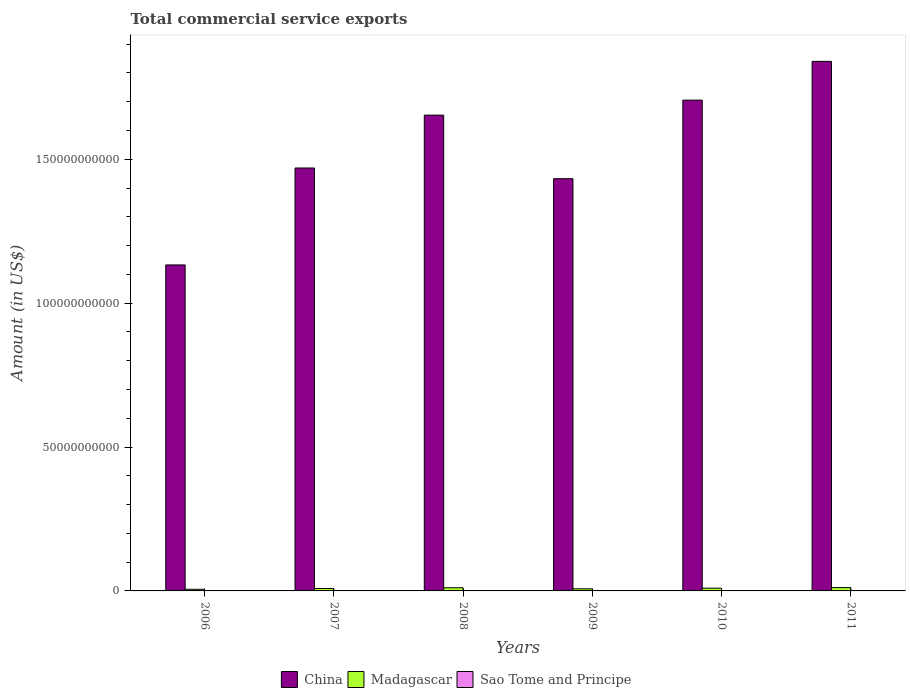Are the number of bars per tick equal to the number of legend labels?
Give a very brief answer. Yes. Are the number of bars on each tick of the X-axis equal?
Ensure brevity in your answer.  Yes. What is the label of the 3rd group of bars from the left?
Ensure brevity in your answer.  2008. What is the total commercial service exports in Sao Tome and Principe in 2009?
Provide a short and direct response. 1.01e+07. Across all years, what is the maximum total commercial service exports in China?
Offer a very short reply. 1.84e+11. Across all years, what is the minimum total commercial service exports in Sao Tome and Principe?
Give a very brief answer. 6.43e+06. In which year was the total commercial service exports in Sao Tome and Principe maximum?
Provide a short and direct response. 2011. What is the total total commercial service exports in China in the graph?
Provide a short and direct response. 9.23e+11. What is the difference between the total commercial service exports in Madagascar in 2009 and that in 2010?
Give a very brief answer. -2.25e+08. What is the difference between the total commercial service exports in China in 2009 and the total commercial service exports in Madagascar in 2006?
Offer a terse response. 1.43e+11. What is the average total commercial service exports in China per year?
Provide a short and direct response. 1.54e+11. In the year 2006, what is the difference between the total commercial service exports in Madagascar and total commercial service exports in Sao Tome and Principe?
Give a very brief answer. 5.56e+08. In how many years, is the total commercial service exports in China greater than 60000000000 US$?
Provide a short and direct response. 6. What is the ratio of the total commercial service exports in Madagascar in 2010 to that in 2011?
Your answer should be compact. 0.83. What is the difference between the highest and the second highest total commercial service exports in Sao Tome and Principe?
Your answer should be compact. 4.98e+06. What is the difference between the highest and the lowest total commercial service exports in China?
Provide a short and direct response. 7.07e+1. What does the 2nd bar from the left in 2009 represents?
Offer a very short reply. Madagascar. What does the 1st bar from the right in 2009 represents?
Give a very brief answer. Sao Tome and Principe. Is it the case that in every year, the sum of the total commercial service exports in Sao Tome and Principe and total commercial service exports in China is greater than the total commercial service exports in Madagascar?
Your answer should be very brief. Yes. How many bars are there?
Offer a very short reply. 18. How many years are there in the graph?
Ensure brevity in your answer.  6. What is the difference between two consecutive major ticks on the Y-axis?
Provide a short and direct response. 5.00e+1. Are the values on the major ticks of Y-axis written in scientific E-notation?
Keep it short and to the point. No. Does the graph contain any zero values?
Your response must be concise. No. How many legend labels are there?
Provide a short and direct response. 3. What is the title of the graph?
Your answer should be very brief. Total commercial service exports. Does "High income" appear as one of the legend labels in the graph?
Make the answer very short. No. What is the Amount (in US$) in China in 2006?
Give a very brief answer. 1.13e+11. What is the Amount (in US$) in Madagascar in 2006?
Ensure brevity in your answer.  5.65e+08. What is the Amount (in US$) in Sao Tome and Principe in 2006?
Your response must be concise. 8.14e+06. What is the Amount (in US$) of China in 2007?
Your response must be concise. 1.47e+11. What is the Amount (in US$) of Madagascar in 2007?
Provide a short and direct response. 8.46e+08. What is the Amount (in US$) in Sao Tome and Principe in 2007?
Give a very brief answer. 6.43e+06. What is the Amount (in US$) of China in 2008?
Make the answer very short. 1.65e+11. What is the Amount (in US$) in Madagascar in 2008?
Provide a short and direct response. 1.10e+09. What is the Amount (in US$) in Sao Tome and Principe in 2008?
Ensure brevity in your answer.  9.37e+06. What is the Amount (in US$) in China in 2009?
Offer a terse response. 1.43e+11. What is the Amount (in US$) of Madagascar in 2009?
Your response must be concise. 7.36e+08. What is the Amount (in US$) of Sao Tome and Principe in 2009?
Your answer should be compact. 1.01e+07. What is the Amount (in US$) in China in 2010?
Provide a succinct answer. 1.71e+11. What is the Amount (in US$) in Madagascar in 2010?
Provide a succinct answer. 9.61e+08. What is the Amount (in US$) in Sao Tome and Principe in 2010?
Provide a succinct answer. 1.30e+07. What is the Amount (in US$) in China in 2011?
Keep it short and to the point. 1.84e+11. What is the Amount (in US$) of Madagascar in 2011?
Your response must be concise. 1.16e+09. What is the Amount (in US$) in Sao Tome and Principe in 2011?
Keep it short and to the point. 1.80e+07. Across all years, what is the maximum Amount (in US$) in China?
Provide a succinct answer. 1.84e+11. Across all years, what is the maximum Amount (in US$) in Madagascar?
Your answer should be compact. 1.16e+09. Across all years, what is the maximum Amount (in US$) in Sao Tome and Principe?
Provide a succinct answer. 1.80e+07. Across all years, what is the minimum Amount (in US$) in China?
Your answer should be compact. 1.13e+11. Across all years, what is the minimum Amount (in US$) in Madagascar?
Offer a very short reply. 5.65e+08. Across all years, what is the minimum Amount (in US$) of Sao Tome and Principe?
Provide a short and direct response. 6.43e+06. What is the total Amount (in US$) in China in the graph?
Give a very brief answer. 9.23e+11. What is the total Amount (in US$) in Madagascar in the graph?
Give a very brief answer. 5.37e+09. What is the total Amount (in US$) of Sao Tome and Principe in the graph?
Your answer should be compact. 6.50e+07. What is the difference between the Amount (in US$) in China in 2006 and that in 2007?
Give a very brief answer. -3.37e+1. What is the difference between the Amount (in US$) in Madagascar in 2006 and that in 2007?
Offer a terse response. -2.82e+08. What is the difference between the Amount (in US$) of Sao Tome and Principe in 2006 and that in 2007?
Give a very brief answer. 1.71e+06. What is the difference between the Amount (in US$) in China in 2006 and that in 2008?
Your answer should be very brief. -5.21e+1. What is the difference between the Amount (in US$) of Madagascar in 2006 and that in 2008?
Make the answer very short. -5.37e+08. What is the difference between the Amount (in US$) of Sao Tome and Principe in 2006 and that in 2008?
Your answer should be very brief. -1.23e+06. What is the difference between the Amount (in US$) in China in 2006 and that in 2009?
Offer a terse response. -3.00e+1. What is the difference between the Amount (in US$) of Madagascar in 2006 and that in 2009?
Give a very brief answer. -1.71e+08. What is the difference between the Amount (in US$) in Sao Tome and Principe in 2006 and that in 2009?
Your answer should be compact. -1.94e+06. What is the difference between the Amount (in US$) of China in 2006 and that in 2010?
Make the answer very short. -5.73e+1. What is the difference between the Amount (in US$) of Madagascar in 2006 and that in 2010?
Your answer should be very brief. -3.97e+08. What is the difference between the Amount (in US$) of Sao Tome and Principe in 2006 and that in 2010?
Your answer should be compact. -4.89e+06. What is the difference between the Amount (in US$) of China in 2006 and that in 2011?
Your response must be concise. -7.07e+1. What is the difference between the Amount (in US$) of Madagascar in 2006 and that in 2011?
Provide a short and direct response. -5.96e+08. What is the difference between the Amount (in US$) of Sao Tome and Principe in 2006 and that in 2011?
Offer a terse response. -9.87e+06. What is the difference between the Amount (in US$) in China in 2007 and that in 2008?
Your response must be concise. -1.84e+1. What is the difference between the Amount (in US$) of Madagascar in 2007 and that in 2008?
Make the answer very short. -2.55e+08. What is the difference between the Amount (in US$) in Sao Tome and Principe in 2007 and that in 2008?
Your response must be concise. -2.94e+06. What is the difference between the Amount (in US$) of China in 2007 and that in 2009?
Offer a terse response. 3.72e+09. What is the difference between the Amount (in US$) in Madagascar in 2007 and that in 2009?
Give a very brief answer. 1.10e+08. What is the difference between the Amount (in US$) of Sao Tome and Principe in 2007 and that in 2009?
Your answer should be compact. -3.64e+06. What is the difference between the Amount (in US$) in China in 2007 and that in 2010?
Provide a succinct answer. -2.36e+1. What is the difference between the Amount (in US$) in Madagascar in 2007 and that in 2010?
Ensure brevity in your answer.  -1.15e+08. What is the difference between the Amount (in US$) of Sao Tome and Principe in 2007 and that in 2010?
Provide a short and direct response. -6.59e+06. What is the difference between the Amount (in US$) in China in 2007 and that in 2011?
Your response must be concise. -3.71e+1. What is the difference between the Amount (in US$) in Madagascar in 2007 and that in 2011?
Your response must be concise. -3.14e+08. What is the difference between the Amount (in US$) in Sao Tome and Principe in 2007 and that in 2011?
Give a very brief answer. -1.16e+07. What is the difference between the Amount (in US$) in China in 2008 and that in 2009?
Offer a very short reply. 2.21e+1. What is the difference between the Amount (in US$) in Madagascar in 2008 and that in 2009?
Your answer should be compact. 3.65e+08. What is the difference between the Amount (in US$) of Sao Tome and Principe in 2008 and that in 2009?
Give a very brief answer. -7.04e+05. What is the difference between the Amount (in US$) of China in 2008 and that in 2010?
Your answer should be very brief. -5.21e+09. What is the difference between the Amount (in US$) in Madagascar in 2008 and that in 2010?
Your answer should be very brief. 1.40e+08. What is the difference between the Amount (in US$) of Sao Tome and Principe in 2008 and that in 2010?
Provide a succinct answer. -3.65e+06. What is the difference between the Amount (in US$) of China in 2008 and that in 2011?
Your answer should be compact. -1.87e+1. What is the difference between the Amount (in US$) in Madagascar in 2008 and that in 2011?
Ensure brevity in your answer.  -5.88e+07. What is the difference between the Amount (in US$) in Sao Tome and Principe in 2008 and that in 2011?
Provide a short and direct response. -8.64e+06. What is the difference between the Amount (in US$) in China in 2009 and that in 2010?
Offer a terse response. -2.73e+1. What is the difference between the Amount (in US$) of Madagascar in 2009 and that in 2010?
Your response must be concise. -2.25e+08. What is the difference between the Amount (in US$) in Sao Tome and Principe in 2009 and that in 2010?
Offer a terse response. -2.95e+06. What is the difference between the Amount (in US$) of China in 2009 and that in 2011?
Keep it short and to the point. -4.08e+1. What is the difference between the Amount (in US$) of Madagascar in 2009 and that in 2011?
Offer a terse response. -4.24e+08. What is the difference between the Amount (in US$) of Sao Tome and Principe in 2009 and that in 2011?
Offer a terse response. -7.93e+06. What is the difference between the Amount (in US$) in China in 2010 and that in 2011?
Give a very brief answer. -1.35e+1. What is the difference between the Amount (in US$) in Madagascar in 2010 and that in 2011?
Your answer should be very brief. -1.99e+08. What is the difference between the Amount (in US$) in Sao Tome and Principe in 2010 and that in 2011?
Provide a succinct answer. -4.98e+06. What is the difference between the Amount (in US$) in China in 2006 and the Amount (in US$) in Madagascar in 2007?
Your response must be concise. 1.12e+11. What is the difference between the Amount (in US$) in China in 2006 and the Amount (in US$) in Sao Tome and Principe in 2007?
Keep it short and to the point. 1.13e+11. What is the difference between the Amount (in US$) of Madagascar in 2006 and the Amount (in US$) of Sao Tome and Principe in 2007?
Provide a short and direct response. 5.58e+08. What is the difference between the Amount (in US$) in China in 2006 and the Amount (in US$) in Madagascar in 2008?
Offer a very short reply. 1.12e+11. What is the difference between the Amount (in US$) in China in 2006 and the Amount (in US$) in Sao Tome and Principe in 2008?
Give a very brief answer. 1.13e+11. What is the difference between the Amount (in US$) of Madagascar in 2006 and the Amount (in US$) of Sao Tome and Principe in 2008?
Provide a succinct answer. 5.55e+08. What is the difference between the Amount (in US$) in China in 2006 and the Amount (in US$) in Madagascar in 2009?
Offer a very short reply. 1.13e+11. What is the difference between the Amount (in US$) of China in 2006 and the Amount (in US$) of Sao Tome and Principe in 2009?
Your answer should be very brief. 1.13e+11. What is the difference between the Amount (in US$) in Madagascar in 2006 and the Amount (in US$) in Sao Tome and Principe in 2009?
Ensure brevity in your answer.  5.55e+08. What is the difference between the Amount (in US$) in China in 2006 and the Amount (in US$) in Madagascar in 2010?
Provide a succinct answer. 1.12e+11. What is the difference between the Amount (in US$) in China in 2006 and the Amount (in US$) in Sao Tome and Principe in 2010?
Offer a terse response. 1.13e+11. What is the difference between the Amount (in US$) of Madagascar in 2006 and the Amount (in US$) of Sao Tome and Principe in 2010?
Offer a terse response. 5.52e+08. What is the difference between the Amount (in US$) in China in 2006 and the Amount (in US$) in Madagascar in 2011?
Your response must be concise. 1.12e+11. What is the difference between the Amount (in US$) of China in 2006 and the Amount (in US$) of Sao Tome and Principe in 2011?
Your answer should be compact. 1.13e+11. What is the difference between the Amount (in US$) of Madagascar in 2006 and the Amount (in US$) of Sao Tome and Principe in 2011?
Your answer should be compact. 5.47e+08. What is the difference between the Amount (in US$) in China in 2007 and the Amount (in US$) in Madagascar in 2008?
Ensure brevity in your answer.  1.46e+11. What is the difference between the Amount (in US$) in China in 2007 and the Amount (in US$) in Sao Tome and Principe in 2008?
Offer a very short reply. 1.47e+11. What is the difference between the Amount (in US$) of Madagascar in 2007 and the Amount (in US$) of Sao Tome and Principe in 2008?
Provide a succinct answer. 8.37e+08. What is the difference between the Amount (in US$) in China in 2007 and the Amount (in US$) in Madagascar in 2009?
Your response must be concise. 1.46e+11. What is the difference between the Amount (in US$) of China in 2007 and the Amount (in US$) of Sao Tome and Principe in 2009?
Ensure brevity in your answer.  1.47e+11. What is the difference between the Amount (in US$) in Madagascar in 2007 and the Amount (in US$) in Sao Tome and Principe in 2009?
Your answer should be very brief. 8.36e+08. What is the difference between the Amount (in US$) of China in 2007 and the Amount (in US$) of Madagascar in 2010?
Ensure brevity in your answer.  1.46e+11. What is the difference between the Amount (in US$) in China in 2007 and the Amount (in US$) in Sao Tome and Principe in 2010?
Your answer should be compact. 1.47e+11. What is the difference between the Amount (in US$) in Madagascar in 2007 and the Amount (in US$) in Sao Tome and Principe in 2010?
Your answer should be compact. 8.33e+08. What is the difference between the Amount (in US$) in China in 2007 and the Amount (in US$) in Madagascar in 2011?
Your answer should be very brief. 1.46e+11. What is the difference between the Amount (in US$) of China in 2007 and the Amount (in US$) of Sao Tome and Principe in 2011?
Keep it short and to the point. 1.47e+11. What is the difference between the Amount (in US$) in Madagascar in 2007 and the Amount (in US$) in Sao Tome and Principe in 2011?
Ensure brevity in your answer.  8.28e+08. What is the difference between the Amount (in US$) in China in 2008 and the Amount (in US$) in Madagascar in 2009?
Make the answer very short. 1.65e+11. What is the difference between the Amount (in US$) in China in 2008 and the Amount (in US$) in Sao Tome and Principe in 2009?
Your answer should be very brief. 1.65e+11. What is the difference between the Amount (in US$) of Madagascar in 2008 and the Amount (in US$) of Sao Tome and Principe in 2009?
Offer a very short reply. 1.09e+09. What is the difference between the Amount (in US$) of China in 2008 and the Amount (in US$) of Madagascar in 2010?
Your answer should be compact. 1.64e+11. What is the difference between the Amount (in US$) in China in 2008 and the Amount (in US$) in Sao Tome and Principe in 2010?
Keep it short and to the point. 1.65e+11. What is the difference between the Amount (in US$) of Madagascar in 2008 and the Amount (in US$) of Sao Tome and Principe in 2010?
Keep it short and to the point. 1.09e+09. What is the difference between the Amount (in US$) of China in 2008 and the Amount (in US$) of Madagascar in 2011?
Offer a terse response. 1.64e+11. What is the difference between the Amount (in US$) of China in 2008 and the Amount (in US$) of Sao Tome and Principe in 2011?
Offer a very short reply. 1.65e+11. What is the difference between the Amount (in US$) of Madagascar in 2008 and the Amount (in US$) of Sao Tome and Principe in 2011?
Your answer should be very brief. 1.08e+09. What is the difference between the Amount (in US$) in China in 2009 and the Amount (in US$) in Madagascar in 2010?
Your answer should be very brief. 1.42e+11. What is the difference between the Amount (in US$) in China in 2009 and the Amount (in US$) in Sao Tome and Principe in 2010?
Your response must be concise. 1.43e+11. What is the difference between the Amount (in US$) in Madagascar in 2009 and the Amount (in US$) in Sao Tome and Principe in 2010?
Provide a short and direct response. 7.23e+08. What is the difference between the Amount (in US$) in China in 2009 and the Amount (in US$) in Madagascar in 2011?
Keep it short and to the point. 1.42e+11. What is the difference between the Amount (in US$) of China in 2009 and the Amount (in US$) of Sao Tome and Principe in 2011?
Your answer should be very brief. 1.43e+11. What is the difference between the Amount (in US$) in Madagascar in 2009 and the Amount (in US$) in Sao Tome and Principe in 2011?
Your answer should be compact. 7.18e+08. What is the difference between the Amount (in US$) of China in 2010 and the Amount (in US$) of Madagascar in 2011?
Offer a very short reply. 1.69e+11. What is the difference between the Amount (in US$) of China in 2010 and the Amount (in US$) of Sao Tome and Principe in 2011?
Your response must be concise. 1.71e+11. What is the difference between the Amount (in US$) in Madagascar in 2010 and the Amount (in US$) in Sao Tome and Principe in 2011?
Provide a succinct answer. 9.43e+08. What is the average Amount (in US$) in China per year?
Your answer should be very brief. 1.54e+11. What is the average Amount (in US$) in Madagascar per year?
Ensure brevity in your answer.  8.95e+08. What is the average Amount (in US$) in Sao Tome and Principe per year?
Ensure brevity in your answer.  1.08e+07. In the year 2006, what is the difference between the Amount (in US$) in China and Amount (in US$) in Madagascar?
Offer a very short reply. 1.13e+11. In the year 2006, what is the difference between the Amount (in US$) of China and Amount (in US$) of Sao Tome and Principe?
Give a very brief answer. 1.13e+11. In the year 2006, what is the difference between the Amount (in US$) in Madagascar and Amount (in US$) in Sao Tome and Principe?
Give a very brief answer. 5.56e+08. In the year 2007, what is the difference between the Amount (in US$) in China and Amount (in US$) in Madagascar?
Your answer should be very brief. 1.46e+11. In the year 2007, what is the difference between the Amount (in US$) of China and Amount (in US$) of Sao Tome and Principe?
Make the answer very short. 1.47e+11. In the year 2007, what is the difference between the Amount (in US$) in Madagascar and Amount (in US$) in Sao Tome and Principe?
Your response must be concise. 8.40e+08. In the year 2008, what is the difference between the Amount (in US$) of China and Amount (in US$) of Madagascar?
Offer a very short reply. 1.64e+11. In the year 2008, what is the difference between the Amount (in US$) of China and Amount (in US$) of Sao Tome and Principe?
Your response must be concise. 1.65e+11. In the year 2008, what is the difference between the Amount (in US$) of Madagascar and Amount (in US$) of Sao Tome and Principe?
Offer a very short reply. 1.09e+09. In the year 2009, what is the difference between the Amount (in US$) of China and Amount (in US$) of Madagascar?
Make the answer very short. 1.42e+11. In the year 2009, what is the difference between the Amount (in US$) of China and Amount (in US$) of Sao Tome and Principe?
Offer a terse response. 1.43e+11. In the year 2009, what is the difference between the Amount (in US$) in Madagascar and Amount (in US$) in Sao Tome and Principe?
Your response must be concise. 7.26e+08. In the year 2010, what is the difference between the Amount (in US$) in China and Amount (in US$) in Madagascar?
Offer a very short reply. 1.70e+11. In the year 2010, what is the difference between the Amount (in US$) of China and Amount (in US$) of Sao Tome and Principe?
Provide a short and direct response. 1.71e+11. In the year 2010, what is the difference between the Amount (in US$) in Madagascar and Amount (in US$) in Sao Tome and Principe?
Make the answer very short. 9.48e+08. In the year 2011, what is the difference between the Amount (in US$) in China and Amount (in US$) in Madagascar?
Ensure brevity in your answer.  1.83e+11. In the year 2011, what is the difference between the Amount (in US$) of China and Amount (in US$) of Sao Tome and Principe?
Your answer should be compact. 1.84e+11. In the year 2011, what is the difference between the Amount (in US$) in Madagascar and Amount (in US$) in Sao Tome and Principe?
Your response must be concise. 1.14e+09. What is the ratio of the Amount (in US$) in China in 2006 to that in 2007?
Offer a very short reply. 0.77. What is the ratio of the Amount (in US$) of Madagascar in 2006 to that in 2007?
Your answer should be very brief. 0.67. What is the ratio of the Amount (in US$) of Sao Tome and Principe in 2006 to that in 2007?
Make the answer very short. 1.27. What is the ratio of the Amount (in US$) of China in 2006 to that in 2008?
Your answer should be very brief. 0.69. What is the ratio of the Amount (in US$) in Madagascar in 2006 to that in 2008?
Your answer should be compact. 0.51. What is the ratio of the Amount (in US$) in Sao Tome and Principe in 2006 to that in 2008?
Your response must be concise. 0.87. What is the ratio of the Amount (in US$) in China in 2006 to that in 2009?
Ensure brevity in your answer.  0.79. What is the ratio of the Amount (in US$) in Madagascar in 2006 to that in 2009?
Make the answer very short. 0.77. What is the ratio of the Amount (in US$) of Sao Tome and Principe in 2006 to that in 2009?
Provide a short and direct response. 0.81. What is the ratio of the Amount (in US$) in China in 2006 to that in 2010?
Keep it short and to the point. 0.66. What is the ratio of the Amount (in US$) of Madagascar in 2006 to that in 2010?
Keep it short and to the point. 0.59. What is the ratio of the Amount (in US$) in Sao Tome and Principe in 2006 to that in 2010?
Ensure brevity in your answer.  0.62. What is the ratio of the Amount (in US$) in China in 2006 to that in 2011?
Offer a terse response. 0.62. What is the ratio of the Amount (in US$) of Madagascar in 2006 to that in 2011?
Ensure brevity in your answer.  0.49. What is the ratio of the Amount (in US$) of Sao Tome and Principe in 2006 to that in 2011?
Make the answer very short. 0.45. What is the ratio of the Amount (in US$) of China in 2007 to that in 2008?
Ensure brevity in your answer.  0.89. What is the ratio of the Amount (in US$) of Madagascar in 2007 to that in 2008?
Keep it short and to the point. 0.77. What is the ratio of the Amount (in US$) in Sao Tome and Principe in 2007 to that in 2008?
Provide a succinct answer. 0.69. What is the ratio of the Amount (in US$) of Madagascar in 2007 to that in 2009?
Keep it short and to the point. 1.15. What is the ratio of the Amount (in US$) of Sao Tome and Principe in 2007 to that in 2009?
Make the answer very short. 0.64. What is the ratio of the Amount (in US$) of China in 2007 to that in 2010?
Ensure brevity in your answer.  0.86. What is the ratio of the Amount (in US$) of Madagascar in 2007 to that in 2010?
Give a very brief answer. 0.88. What is the ratio of the Amount (in US$) in Sao Tome and Principe in 2007 to that in 2010?
Your answer should be very brief. 0.49. What is the ratio of the Amount (in US$) of China in 2007 to that in 2011?
Offer a terse response. 0.8. What is the ratio of the Amount (in US$) of Madagascar in 2007 to that in 2011?
Provide a short and direct response. 0.73. What is the ratio of the Amount (in US$) in Sao Tome and Principe in 2007 to that in 2011?
Your response must be concise. 0.36. What is the ratio of the Amount (in US$) in China in 2008 to that in 2009?
Give a very brief answer. 1.15. What is the ratio of the Amount (in US$) in Madagascar in 2008 to that in 2009?
Make the answer very short. 1.5. What is the ratio of the Amount (in US$) of Sao Tome and Principe in 2008 to that in 2009?
Give a very brief answer. 0.93. What is the ratio of the Amount (in US$) of China in 2008 to that in 2010?
Your response must be concise. 0.97. What is the ratio of the Amount (in US$) of Madagascar in 2008 to that in 2010?
Offer a very short reply. 1.15. What is the ratio of the Amount (in US$) in Sao Tome and Principe in 2008 to that in 2010?
Give a very brief answer. 0.72. What is the ratio of the Amount (in US$) in China in 2008 to that in 2011?
Keep it short and to the point. 0.9. What is the ratio of the Amount (in US$) of Madagascar in 2008 to that in 2011?
Give a very brief answer. 0.95. What is the ratio of the Amount (in US$) of Sao Tome and Principe in 2008 to that in 2011?
Make the answer very short. 0.52. What is the ratio of the Amount (in US$) of China in 2009 to that in 2010?
Your answer should be compact. 0.84. What is the ratio of the Amount (in US$) of Madagascar in 2009 to that in 2010?
Ensure brevity in your answer.  0.77. What is the ratio of the Amount (in US$) of Sao Tome and Principe in 2009 to that in 2010?
Provide a succinct answer. 0.77. What is the ratio of the Amount (in US$) of China in 2009 to that in 2011?
Provide a short and direct response. 0.78. What is the ratio of the Amount (in US$) of Madagascar in 2009 to that in 2011?
Offer a terse response. 0.63. What is the ratio of the Amount (in US$) in Sao Tome and Principe in 2009 to that in 2011?
Give a very brief answer. 0.56. What is the ratio of the Amount (in US$) in China in 2010 to that in 2011?
Ensure brevity in your answer.  0.93. What is the ratio of the Amount (in US$) in Madagascar in 2010 to that in 2011?
Offer a very short reply. 0.83. What is the ratio of the Amount (in US$) of Sao Tome and Principe in 2010 to that in 2011?
Give a very brief answer. 0.72. What is the difference between the highest and the second highest Amount (in US$) of China?
Ensure brevity in your answer.  1.35e+1. What is the difference between the highest and the second highest Amount (in US$) of Madagascar?
Provide a succinct answer. 5.88e+07. What is the difference between the highest and the second highest Amount (in US$) of Sao Tome and Principe?
Keep it short and to the point. 4.98e+06. What is the difference between the highest and the lowest Amount (in US$) in China?
Provide a short and direct response. 7.07e+1. What is the difference between the highest and the lowest Amount (in US$) of Madagascar?
Make the answer very short. 5.96e+08. What is the difference between the highest and the lowest Amount (in US$) in Sao Tome and Principe?
Provide a short and direct response. 1.16e+07. 